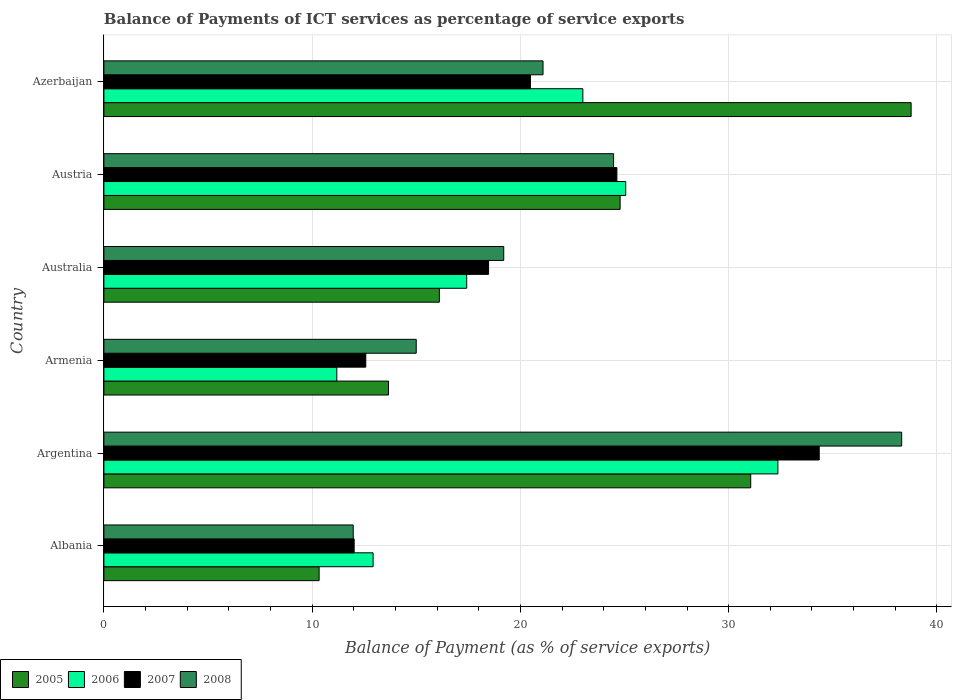How many different coloured bars are there?
Provide a succinct answer. 4. Are the number of bars per tick equal to the number of legend labels?
Offer a terse response. Yes. How many bars are there on the 6th tick from the top?
Provide a succinct answer. 4. What is the label of the 4th group of bars from the top?
Make the answer very short. Armenia. In how many cases, is the number of bars for a given country not equal to the number of legend labels?
Provide a short and direct response. 0. What is the balance of payments of ICT services in 2005 in Australia?
Keep it short and to the point. 16.11. Across all countries, what is the maximum balance of payments of ICT services in 2006?
Provide a succinct answer. 32.36. Across all countries, what is the minimum balance of payments of ICT services in 2007?
Provide a short and direct response. 12.02. In which country was the balance of payments of ICT services in 2007 maximum?
Offer a terse response. Argentina. In which country was the balance of payments of ICT services in 2005 minimum?
Ensure brevity in your answer.  Albania. What is the total balance of payments of ICT services in 2007 in the graph?
Keep it short and to the point. 122.53. What is the difference between the balance of payments of ICT services in 2007 in Argentina and that in Australia?
Make the answer very short. 15.88. What is the difference between the balance of payments of ICT services in 2006 in Albania and the balance of payments of ICT services in 2008 in Argentina?
Offer a terse response. -25.38. What is the average balance of payments of ICT services in 2007 per country?
Your answer should be compact. 20.42. What is the difference between the balance of payments of ICT services in 2008 and balance of payments of ICT services in 2005 in Armenia?
Ensure brevity in your answer.  1.33. In how many countries, is the balance of payments of ICT services in 2005 greater than 32 %?
Your answer should be compact. 1. What is the ratio of the balance of payments of ICT services in 2007 in Albania to that in Austria?
Make the answer very short. 0.49. Is the difference between the balance of payments of ICT services in 2008 in Armenia and Azerbaijan greater than the difference between the balance of payments of ICT services in 2005 in Armenia and Azerbaijan?
Ensure brevity in your answer.  Yes. What is the difference between the highest and the second highest balance of payments of ICT services in 2006?
Keep it short and to the point. 7.31. What is the difference between the highest and the lowest balance of payments of ICT services in 2005?
Give a very brief answer. 28.43. In how many countries, is the balance of payments of ICT services in 2006 greater than the average balance of payments of ICT services in 2006 taken over all countries?
Provide a short and direct response. 3. What does the 2nd bar from the top in Azerbaijan represents?
Give a very brief answer. 2007. What does the 4th bar from the bottom in Argentina represents?
Your answer should be compact. 2008. Is it the case that in every country, the sum of the balance of payments of ICT services in 2006 and balance of payments of ICT services in 2005 is greater than the balance of payments of ICT services in 2008?
Give a very brief answer. Yes. How many bars are there?
Provide a short and direct response. 24. How many countries are there in the graph?
Your response must be concise. 6. What is the difference between two consecutive major ticks on the X-axis?
Your response must be concise. 10. Are the values on the major ticks of X-axis written in scientific E-notation?
Provide a succinct answer. No. Does the graph contain grids?
Ensure brevity in your answer.  Yes. Where does the legend appear in the graph?
Offer a terse response. Bottom left. How many legend labels are there?
Make the answer very short. 4. How are the legend labels stacked?
Give a very brief answer. Horizontal. What is the title of the graph?
Give a very brief answer. Balance of Payments of ICT services as percentage of service exports. Does "2000" appear as one of the legend labels in the graph?
Offer a very short reply. No. What is the label or title of the X-axis?
Give a very brief answer. Balance of Payment (as % of service exports). What is the label or title of the Y-axis?
Keep it short and to the point. Country. What is the Balance of Payment (as % of service exports) of 2005 in Albania?
Ensure brevity in your answer.  10.34. What is the Balance of Payment (as % of service exports) of 2006 in Albania?
Your response must be concise. 12.93. What is the Balance of Payment (as % of service exports) in 2007 in Albania?
Offer a very short reply. 12.02. What is the Balance of Payment (as % of service exports) of 2008 in Albania?
Offer a terse response. 11.97. What is the Balance of Payment (as % of service exports) of 2005 in Argentina?
Make the answer very short. 31.06. What is the Balance of Payment (as % of service exports) of 2006 in Argentina?
Offer a terse response. 32.36. What is the Balance of Payment (as % of service exports) of 2007 in Argentina?
Make the answer very short. 34.35. What is the Balance of Payment (as % of service exports) of 2008 in Argentina?
Your answer should be compact. 38.31. What is the Balance of Payment (as % of service exports) in 2005 in Armenia?
Keep it short and to the point. 13.67. What is the Balance of Payment (as % of service exports) of 2006 in Armenia?
Your answer should be compact. 11.18. What is the Balance of Payment (as % of service exports) of 2007 in Armenia?
Your response must be concise. 12.58. What is the Balance of Payment (as % of service exports) of 2008 in Armenia?
Your response must be concise. 15. What is the Balance of Payment (as % of service exports) of 2005 in Australia?
Your answer should be compact. 16.11. What is the Balance of Payment (as % of service exports) of 2006 in Australia?
Offer a very short reply. 17.42. What is the Balance of Payment (as % of service exports) in 2007 in Australia?
Ensure brevity in your answer.  18.47. What is the Balance of Payment (as % of service exports) in 2008 in Australia?
Give a very brief answer. 19.2. What is the Balance of Payment (as % of service exports) of 2005 in Austria?
Your response must be concise. 24.79. What is the Balance of Payment (as % of service exports) in 2006 in Austria?
Your answer should be very brief. 25.06. What is the Balance of Payment (as % of service exports) in 2007 in Austria?
Your answer should be compact. 24.63. What is the Balance of Payment (as % of service exports) of 2008 in Austria?
Make the answer very short. 24.47. What is the Balance of Payment (as % of service exports) of 2005 in Azerbaijan?
Offer a very short reply. 38.76. What is the Balance of Payment (as % of service exports) in 2006 in Azerbaijan?
Ensure brevity in your answer.  23. What is the Balance of Payment (as % of service exports) in 2007 in Azerbaijan?
Offer a terse response. 20.48. What is the Balance of Payment (as % of service exports) of 2008 in Azerbaijan?
Offer a terse response. 21.09. Across all countries, what is the maximum Balance of Payment (as % of service exports) of 2005?
Your answer should be very brief. 38.76. Across all countries, what is the maximum Balance of Payment (as % of service exports) of 2006?
Offer a terse response. 32.36. Across all countries, what is the maximum Balance of Payment (as % of service exports) in 2007?
Your response must be concise. 34.35. Across all countries, what is the maximum Balance of Payment (as % of service exports) in 2008?
Your answer should be very brief. 38.31. Across all countries, what is the minimum Balance of Payment (as % of service exports) in 2005?
Offer a terse response. 10.34. Across all countries, what is the minimum Balance of Payment (as % of service exports) in 2006?
Ensure brevity in your answer.  11.18. Across all countries, what is the minimum Balance of Payment (as % of service exports) in 2007?
Keep it short and to the point. 12.02. Across all countries, what is the minimum Balance of Payment (as % of service exports) of 2008?
Your response must be concise. 11.97. What is the total Balance of Payment (as % of service exports) in 2005 in the graph?
Your response must be concise. 134.72. What is the total Balance of Payment (as % of service exports) in 2006 in the graph?
Give a very brief answer. 121.95. What is the total Balance of Payment (as % of service exports) in 2007 in the graph?
Offer a very short reply. 122.53. What is the total Balance of Payment (as % of service exports) in 2008 in the graph?
Your answer should be very brief. 130.04. What is the difference between the Balance of Payment (as % of service exports) of 2005 in Albania and that in Argentina?
Your response must be concise. -20.72. What is the difference between the Balance of Payment (as % of service exports) of 2006 in Albania and that in Argentina?
Make the answer very short. -19.44. What is the difference between the Balance of Payment (as % of service exports) of 2007 in Albania and that in Argentina?
Your answer should be compact. -22.33. What is the difference between the Balance of Payment (as % of service exports) of 2008 in Albania and that in Argentina?
Your response must be concise. -26.34. What is the difference between the Balance of Payment (as % of service exports) in 2005 in Albania and that in Armenia?
Give a very brief answer. -3.33. What is the difference between the Balance of Payment (as % of service exports) in 2006 in Albania and that in Armenia?
Offer a terse response. 1.74. What is the difference between the Balance of Payment (as % of service exports) in 2007 in Albania and that in Armenia?
Keep it short and to the point. -0.56. What is the difference between the Balance of Payment (as % of service exports) in 2008 in Albania and that in Armenia?
Provide a short and direct response. -3.03. What is the difference between the Balance of Payment (as % of service exports) in 2005 in Albania and that in Australia?
Your response must be concise. -5.77. What is the difference between the Balance of Payment (as % of service exports) in 2006 in Albania and that in Australia?
Give a very brief answer. -4.5. What is the difference between the Balance of Payment (as % of service exports) in 2007 in Albania and that in Australia?
Keep it short and to the point. -6.45. What is the difference between the Balance of Payment (as % of service exports) of 2008 in Albania and that in Australia?
Offer a terse response. -7.23. What is the difference between the Balance of Payment (as % of service exports) of 2005 in Albania and that in Austria?
Provide a succinct answer. -14.45. What is the difference between the Balance of Payment (as % of service exports) of 2006 in Albania and that in Austria?
Your response must be concise. -12.13. What is the difference between the Balance of Payment (as % of service exports) in 2007 in Albania and that in Austria?
Offer a very short reply. -12.62. What is the difference between the Balance of Payment (as % of service exports) of 2008 in Albania and that in Austria?
Provide a succinct answer. -12.5. What is the difference between the Balance of Payment (as % of service exports) in 2005 in Albania and that in Azerbaijan?
Offer a terse response. -28.43. What is the difference between the Balance of Payment (as % of service exports) of 2006 in Albania and that in Azerbaijan?
Ensure brevity in your answer.  -10.07. What is the difference between the Balance of Payment (as % of service exports) of 2007 in Albania and that in Azerbaijan?
Give a very brief answer. -8.46. What is the difference between the Balance of Payment (as % of service exports) in 2008 in Albania and that in Azerbaijan?
Ensure brevity in your answer.  -9.11. What is the difference between the Balance of Payment (as % of service exports) of 2005 in Argentina and that in Armenia?
Provide a short and direct response. 17.39. What is the difference between the Balance of Payment (as % of service exports) in 2006 in Argentina and that in Armenia?
Give a very brief answer. 21.18. What is the difference between the Balance of Payment (as % of service exports) of 2007 in Argentina and that in Armenia?
Offer a terse response. 21.77. What is the difference between the Balance of Payment (as % of service exports) in 2008 in Argentina and that in Armenia?
Give a very brief answer. 23.31. What is the difference between the Balance of Payment (as % of service exports) in 2005 in Argentina and that in Australia?
Give a very brief answer. 14.95. What is the difference between the Balance of Payment (as % of service exports) in 2006 in Argentina and that in Australia?
Your answer should be compact. 14.94. What is the difference between the Balance of Payment (as % of service exports) of 2007 in Argentina and that in Australia?
Provide a succinct answer. 15.88. What is the difference between the Balance of Payment (as % of service exports) of 2008 in Argentina and that in Australia?
Ensure brevity in your answer.  19.11. What is the difference between the Balance of Payment (as % of service exports) of 2005 in Argentina and that in Austria?
Offer a terse response. 6.27. What is the difference between the Balance of Payment (as % of service exports) of 2006 in Argentina and that in Austria?
Your answer should be very brief. 7.31. What is the difference between the Balance of Payment (as % of service exports) of 2007 in Argentina and that in Austria?
Keep it short and to the point. 9.72. What is the difference between the Balance of Payment (as % of service exports) in 2008 in Argentina and that in Austria?
Offer a very short reply. 13.83. What is the difference between the Balance of Payment (as % of service exports) in 2005 in Argentina and that in Azerbaijan?
Your response must be concise. -7.7. What is the difference between the Balance of Payment (as % of service exports) of 2006 in Argentina and that in Azerbaijan?
Make the answer very short. 9.37. What is the difference between the Balance of Payment (as % of service exports) in 2007 in Argentina and that in Azerbaijan?
Offer a very short reply. 13.87. What is the difference between the Balance of Payment (as % of service exports) in 2008 in Argentina and that in Azerbaijan?
Make the answer very short. 17.22. What is the difference between the Balance of Payment (as % of service exports) of 2005 in Armenia and that in Australia?
Offer a terse response. -2.44. What is the difference between the Balance of Payment (as % of service exports) in 2006 in Armenia and that in Australia?
Offer a very short reply. -6.24. What is the difference between the Balance of Payment (as % of service exports) in 2007 in Armenia and that in Australia?
Your response must be concise. -5.9. What is the difference between the Balance of Payment (as % of service exports) in 2008 in Armenia and that in Australia?
Keep it short and to the point. -4.2. What is the difference between the Balance of Payment (as % of service exports) of 2005 in Armenia and that in Austria?
Offer a terse response. -11.12. What is the difference between the Balance of Payment (as % of service exports) of 2006 in Armenia and that in Austria?
Offer a very short reply. -13.87. What is the difference between the Balance of Payment (as % of service exports) in 2007 in Armenia and that in Austria?
Your answer should be very brief. -12.06. What is the difference between the Balance of Payment (as % of service exports) of 2008 in Armenia and that in Austria?
Your answer should be very brief. -9.48. What is the difference between the Balance of Payment (as % of service exports) in 2005 in Armenia and that in Azerbaijan?
Your response must be concise. -25.1. What is the difference between the Balance of Payment (as % of service exports) in 2006 in Armenia and that in Azerbaijan?
Your answer should be compact. -11.81. What is the difference between the Balance of Payment (as % of service exports) of 2007 in Armenia and that in Azerbaijan?
Ensure brevity in your answer.  -7.9. What is the difference between the Balance of Payment (as % of service exports) in 2008 in Armenia and that in Azerbaijan?
Your answer should be very brief. -6.09. What is the difference between the Balance of Payment (as % of service exports) of 2005 in Australia and that in Austria?
Provide a short and direct response. -8.68. What is the difference between the Balance of Payment (as % of service exports) of 2006 in Australia and that in Austria?
Make the answer very short. -7.63. What is the difference between the Balance of Payment (as % of service exports) in 2007 in Australia and that in Austria?
Ensure brevity in your answer.  -6.16. What is the difference between the Balance of Payment (as % of service exports) in 2008 in Australia and that in Austria?
Make the answer very short. -5.28. What is the difference between the Balance of Payment (as % of service exports) in 2005 in Australia and that in Azerbaijan?
Your answer should be compact. -22.65. What is the difference between the Balance of Payment (as % of service exports) of 2006 in Australia and that in Azerbaijan?
Keep it short and to the point. -5.58. What is the difference between the Balance of Payment (as % of service exports) in 2007 in Australia and that in Azerbaijan?
Your answer should be compact. -2.01. What is the difference between the Balance of Payment (as % of service exports) of 2008 in Australia and that in Azerbaijan?
Your response must be concise. -1.89. What is the difference between the Balance of Payment (as % of service exports) in 2005 in Austria and that in Azerbaijan?
Your response must be concise. -13.97. What is the difference between the Balance of Payment (as % of service exports) in 2006 in Austria and that in Azerbaijan?
Provide a succinct answer. 2.06. What is the difference between the Balance of Payment (as % of service exports) in 2007 in Austria and that in Azerbaijan?
Make the answer very short. 4.15. What is the difference between the Balance of Payment (as % of service exports) in 2008 in Austria and that in Azerbaijan?
Give a very brief answer. 3.39. What is the difference between the Balance of Payment (as % of service exports) in 2005 in Albania and the Balance of Payment (as % of service exports) in 2006 in Argentina?
Offer a very short reply. -22.03. What is the difference between the Balance of Payment (as % of service exports) in 2005 in Albania and the Balance of Payment (as % of service exports) in 2007 in Argentina?
Ensure brevity in your answer.  -24.01. What is the difference between the Balance of Payment (as % of service exports) of 2005 in Albania and the Balance of Payment (as % of service exports) of 2008 in Argentina?
Your answer should be very brief. -27.97. What is the difference between the Balance of Payment (as % of service exports) of 2006 in Albania and the Balance of Payment (as % of service exports) of 2007 in Argentina?
Make the answer very short. -21.42. What is the difference between the Balance of Payment (as % of service exports) of 2006 in Albania and the Balance of Payment (as % of service exports) of 2008 in Argentina?
Give a very brief answer. -25.38. What is the difference between the Balance of Payment (as % of service exports) in 2007 in Albania and the Balance of Payment (as % of service exports) in 2008 in Argentina?
Provide a succinct answer. -26.29. What is the difference between the Balance of Payment (as % of service exports) in 2005 in Albania and the Balance of Payment (as % of service exports) in 2006 in Armenia?
Offer a very short reply. -0.85. What is the difference between the Balance of Payment (as % of service exports) of 2005 in Albania and the Balance of Payment (as % of service exports) of 2007 in Armenia?
Provide a succinct answer. -2.24. What is the difference between the Balance of Payment (as % of service exports) of 2005 in Albania and the Balance of Payment (as % of service exports) of 2008 in Armenia?
Offer a terse response. -4.66. What is the difference between the Balance of Payment (as % of service exports) in 2006 in Albania and the Balance of Payment (as % of service exports) in 2007 in Armenia?
Your response must be concise. 0.35. What is the difference between the Balance of Payment (as % of service exports) in 2006 in Albania and the Balance of Payment (as % of service exports) in 2008 in Armenia?
Keep it short and to the point. -2.07. What is the difference between the Balance of Payment (as % of service exports) of 2007 in Albania and the Balance of Payment (as % of service exports) of 2008 in Armenia?
Give a very brief answer. -2.98. What is the difference between the Balance of Payment (as % of service exports) of 2005 in Albania and the Balance of Payment (as % of service exports) of 2006 in Australia?
Offer a very short reply. -7.09. What is the difference between the Balance of Payment (as % of service exports) of 2005 in Albania and the Balance of Payment (as % of service exports) of 2007 in Australia?
Provide a succinct answer. -8.14. What is the difference between the Balance of Payment (as % of service exports) of 2005 in Albania and the Balance of Payment (as % of service exports) of 2008 in Australia?
Your response must be concise. -8.86. What is the difference between the Balance of Payment (as % of service exports) of 2006 in Albania and the Balance of Payment (as % of service exports) of 2007 in Australia?
Ensure brevity in your answer.  -5.55. What is the difference between the Balance of Payment (as % of service exports) of 2006 in Albania and the Balance of Payment (as % of service exports) of 2008 in Australia?
Make the answer very short. -6.27. What is the difference between the Balance of Payment (as % of service exports) of 2007 in Albania and the Balance of Payment (as % of service exports) of 2008 in Australia?
Your response must be concise. -7.18. What is the difference between the Balance of Payment (as % of service exports) of 2005 in Albania and the Balance of Payment (as % of service exports) of 2006 in Austria?
Ensure brevity in your answer.  -14.72. What is the difference between the Balance of Payment (as % of service exports) of 2005 in Albania and the Balance of Payment (as % of service exports) of 2007 in Austria?
Your answer should be very brief. -14.3. What is the difference between the Balance of Payment (as % of service exports) of 2005 in Albania and the Balance of Payment (as % of service exports) of 2008 in Austria?
Give a very brief answer. -14.14. What is the difference between the Balance of Payment (as % of service exports) in 2006 in Albania and the Balance of Payment (as % of service exports) in 2007 in Austria?
Your answer should be very brief. -11.71. What is the difference between the Balance of Payment (as % of service exports) of 2006 in Albania and the Balance of Payment (as % of service exports) of 2008 in Austria?
Provide a short and direct response. -11.55. What is the difference between the Balance of Payment (as % of service exports) of 2007 in Albania and the Balance of Payment (as % of service exports) of 2008 in Austria?
Make the answer very short. -12.46. What is the difference between the Balance of Payment (as % of service exports) of 2005 in Albania and the Balance of Payment (as % of service exports) of 2006 in Azerbaijan?
Your answer should be compact. -12.66. What is the difference between the Balance of Payment (as % of service exports) of 2005 in Albania and the Balance of Payment (as % of service exports) of 2007 in Azerbaijan?
Your answer should be very brief. -10.15. What is the difference between the Balance of Payment (as % of service exports) in 2005 in Albania and the Balance of Payment (as % of service exports) in 2008 in Azerbaijan?
Offer a very short reply. -10.75. What is the difference between the Balance of Payment (as % of service exports) in 2006 in Albania and the Balance of Payment (as % of service exports) in 2007 in Azerbaijan?
Your answer should be very brief. -7.55. What is the difference between the Balance of Payment (as % of service exports) in 2006 in Albania and the Balance of Payment (as % of service exports) in 2008 in Azerbaijan?
Your response must be concise. -8.16. What is the difference between the Balance of Payment (as % of service exports) of 2007 in Albania and the Balance of Payment (as % of service exports) of 2008 in Azerbaijan?
Your answer should be compact. -9.07. What is the difference between the Balance of Payment (as % of service exports) in 2005 in Argentina and the Balance of Payment (as % of service exports) in 2006 in Armenia?
Ensure brevity in your answer.  19.87. What is the difference between the Balance of Payment (as % of service exports) in 2005 in Argentina and the Balance of Payment (as % of service exports) in 2007 in Armenia?
Give a very brief answer. 18.48. What is the difference between the Balance of Payment (as % of service exports) of 2005 in Argentina and the Balance of Payment (as % of service exports) of 2008 in Armenia?
Your response must be concise. 16.06. What is the difference between the Balance of Payment (as % of service exports) in 2006 in Argentina and the Balance of Payment (as % of service exports) in 2007 in Armenia?
Offer a terse response. 19.79. What is the difference between the Balance of Payment (as % of service exports) of 2006 in Argentina and the Balance of Payment (as % of service exports) of 2008 in Armenia?
Offer a very short reply. 17.37. What is the difference between the Balance of Payment (as % of service exports) of 2007 in Argentina and the Balance of Payment (as % of service exports) of 2008 in Armenia?
Give a very brief answer. 19.35. What is the difference between the Balance of Payment (as % of service exports) of 2005 in Argentina and the Balance of Payment (as % of service exports) of 2006 in Australia?
Offer a very short reply. 13.64. What is the difference between the Balance of Payment (as % of service exports) of 2005 in Argentina and the Balance of Payment (as % of service exports) of 2007 in Australia?
Ensure brevity in your answer.  12.59. What is the difference between the Balance of Payment (as % of service exports) in 2005 in Argentina and the Balance of Payment (as % of service exports) in 2008 in Australia?
Make the answer very short. 11.86. What is the difference between the Balance of Payment (as % of service exports) of 2006 in Argentina and the Balance of Payment (as % of service exports) of 2007 in Australia?
Make the answer very short. 13.89. What is the difference between the Balance of Payment (as % of service exports) of 2006 in Argentina and the Balance of Payment (as % of service exports) of 2008 in Australia?
Your answer should be compact. 13.17. What is the difference between the Balance of Payment (as % of service exports) in 2007 in Argentina and the Balance of Payment (as % of service exports) in 2008 in Australia?
Offer a terse response. 15.15. What is the difference between the Balance of Payment (as % of service exports) of 2005 in Argentina and the Balance of Payment (as % of service exports) of 2006 in Austria?
Give a very brief answer. 6. What is the difference between the Balance of Payment (as % of service exports) in 2005 in Argentina and the Balance of Payment (as % of service exports) in 2007 in Austria?
Provide a succinct answer. 6.43. What is the difference between the Balance of Payment (as % of service exports) in 2005 in Argentina and the Balance of Payment (as % of service exports) in 2008 in Austria?
Your response must be concise. 6.58. What is the difference between the Balance of Payment (as % of service exports) of 2006 in Argentina and the Balance of Payment (as % of service exports) of 2007 in Austria?
Provide a short and direct response. 7.73. What is the difference between the Balance of Payment (as % of service exports) of 2006 in Argentina and the Balance of Payment (as % of service exports) of 2008 in Austria?
Your response must be concise. 7.89. What is the difference between the Balance of Payment (as % of service exports) in 2007 in Argentina and the Balance of Payment (as % of service exports) in 2008 in Austria?
Provide a short and direct response. 9.87. What is the difference between the Balance of Payment (as % of service exports) in 2005 in Argentina and the Balance of Payment (as % of service exports) in 2006 in Azerbaijan?
Provide a succinct answer. 8.06. What is the difference between the Balance of Payment (as % of service exports) of 2005 in Argentina and the Balance of Payment (as % of service exports) of 2007 in Azerbaijan?
Offer a terse response. 10.58. What is the difference between the Balance of Payment (as % of service exports) in 2005 in Argentina and the Balance of Payment (as % of service exports) in 2008 in Azerbaijan?
Provide a succinct answer. 9.97. What is the difference between the Balance of Payment (as % of service exports) of 2006 in Argentina and the Balance of Payment (as % of service exports) of 2007 in Azerbaijan?
Make the answer very short. 11.88. What is the difference between the Balance of Payment (as % of service exports) of 2006 in Argentina and the Balance of Payment (as % of service exports) of 2008 in Azerbaijan?
Keep it short and to the point. 11.28. What is the difference between the Balance of Payment (as % of service exports) of 2007 in Argentina and the Balance of Payment (as % of service exports) of 2008 in Azerbaijan?
Offer a very short reply. 13.26. What is the difference between the Balance of Payment (as % of service exports) of 2005 in Armenia and the Balance of Payment (as % of service exports) of 2006 in Australia?
Provide a short and direct response. -3.76. What is the difference between the Balance of Payment (as % of service exports) of 2005 in Armenia and the Balance of Payment (as % of service exports) of 2007 in Australia?
Offer a terse response. -4.81. What is the difference between the Balance of Payment (as % of service exports) of 2005 in Armenia and the Balance of Payment (as % of service exports) of 2008 in Australia?
Your response must be concise. -5.53. What is the difference between the Balance of Payment (as % of service exports) in 2006 in Armenia and the Balance of Payment (as % of service exports) in 2007 in Australia?
Make the answer very short. -7.29. What is the difference between the Balance of Payment (as % of service exports) of 2006 in Armenia and the Balance of Payment (as % of service exports) of 2008 in Australia?
Your answer should be compact. -8.02. What is the difference between the Balance of Payment (as % of service exports) of 2007 in Armenia and the Balance of Payment (as % of service exports) of 2008 in Australia?
Your answer should be compact. -6.62. What is the difference between the Balance of Payment (as % of service exports) of 2005 in Armenia and the Balance of Payment (as % of service exports) of 2006 in Austria?
Offer a very short reply. -11.39. What is the difference between the Balance of Payment (as % of service exports) of 2005 in Armenia and the Balance of Payment (as % of service exports) of 2007 in Austria?
Provide a succinct answer. -10.97. What is the difference between the Balance of Payment (as % of service exports) of 2005 in Armenia and the Balance of Payment (as % of service exports) of 2008 in Austria?
Offer a very short reply. -10.81. What is the difference between the Balance of Payment (as % of service exports) of 2006 in Armenia and the Balance of Payment (as % of service exports) of 2007 in Austria?
Your answer should be compact. -13.45. What is the difference between the Balance of Payment (as % of service exports) of 2006 in Armenia and the Balance of Payment (as % of service exports) of 2008 in Austria?
Offer a terse response. -13.29. What is the difference between the Balance of Payment (as % of service exports) of 2007 in Armenia and the Balance of Payment (as % of service exports) of 2008 in Austria?
Give a very brief answer. -11.9. What is the difference between the Balance of Payment (as % of service exports) of 2005 in Armenia and the Balance of Payment (as % of service exports) of 2006 in Azerbaijan?
Provide a succinct answer. -9.33. What is the difference between the Balance of Payment (as % of service exports) in 2005 in Armenia and the Balance of Payment (as % of service exports) in 2007 in Azerbaijan?
Offer a very short reply. -6.81. What is the difference between the Balance of Payment (as % of service exports) of 2005 in Armenia and the Balance of Payment (as % of service exports) of 2008 in Azerbaijan?
Offer a very short reply. -7.42. What is the difference between the Balance of Payment (as % of service exports) in 2006 in Armenia and the Balance of Payment (as % of service exports) in 2007 in Azerbaijan?
Your answer should be very brief. -9.3. What is the difference between the Balance of Payment (as % of service exports) in 2006 in Armenia and the Balance of Payment (as % of service exports) in 2008 in Azerbaijan?
Your response must be concise. -9.9. What is the difference between the Balance of Payment (as % of service exports) of 2007 in Armenia and the Balance of Payment (as % of service exports) of 2008 in Azerbaijan?
Offer a terse response. -8.51. What is the difference between the Balance of Payment (as % of service exports) of 2005 in Australia and the Balance of Payment (as % of service exports) of 2006 in Austria?
Ensure brevity in your answer.  -8.95. What is the difference between the Balance of Payment (as % of service exports) of 2005 in Australia and the Balance of Payment (as % of service exports) of 2007 in Austria?
Offer a very short reply. -8.52. What is the difference between the Balance of Payment (as % of service exports) of 2005 in Australia and the Balance of Payment (as % of service exports) of 2008 in Austria?
Provide a short and direct response. -8.37. What is the difference between the Balance of Payment (as % of service exports) of 2006 in Australia and the Balance of Payment (as % of service exports) of 2007 in Austria?
Provide a succinct answer. -7.21. What is the difference between the Balance of Payment (as % of service exports) of 2006 in Australia and the Balance of Payment (as % of service exports) of 2008 in Austria?
Your response must be concise. -7.05. What is the difference between the Balance of Payment (as % of service exports) of 2007 in Australia and the Balance of Payment (as % of service exports) of 2008 in Austria?
Provide a short and direct response. -6. What is the difference between the Balance of Payment (as % of service exports) in 2005 in Australia and the Balance of Payment (as % of service exports) in 2006 in Azerbaijan?
Your response must be concise. -6.89. What is the difference between the Balance of Payment (as % of service exports) in 2005 in Australia and the Balance of Payment (as % of service exports) in 2007 in Azerbaijan?
Offer a very short reply. -4.37. What is the difference between the Balance of Payment (as % of service exports) in 2005 in Australia and the Balance of Payment (as % of service exports) in 2008 in Azerbaijan?
Your answer should be very brief. -4.98. What is the difference between the Balance of Payment (as % of service exports) of 2006 in Australia and the Balance of Payment (as % of service exports) of 2007 in Azerbaijan?
Give a very brief answer. -3.06. What is the difference between the Balance of Payment (as % of service exports) in 2006 in Australia and the Balance of Payment (as % of service exports) in 2008 in Azerbaijan?
Your answer should be compact. -3.66. What is the difference between the Balance of Payment (as % of service exports) of 2007 in Australia and the Balance of Payment (as % of service exports) of 2008 in Azerbaijan?
Your answer should be compact. -2.61. What is the difference between the Balance of Payment (as % of service exports) in 2005 in Austria and the Balance of Payment (as % of service exports) in 2006 in Azerbaijan?
Your response must be concise. 1.79. What is the difference between the Balance of Payment (as % of service exports) of 2005 in Austria and the Balance of Payment (as % of service exports) of 2007 in Azerbaijan?
Your answer should be compact. 4.31. What is the difference between the Balance of Payment (as % of service exports) of 2005 in Austria and the Balance of Payment (as % of service exports) of 2008 in Azerbaijan?
Provide a succinct answer. 3.7. What is the difference between the Balance of Payment (as % of service exports) in 2006 in Austria and the Balance of Payment (as % of service exports) in 2007 in Azerbaijan?
Offer a terse response. 4.58. What is the difference between the Balance of Payment (as % of service exports) of 2006 in Austria and the Balance of Payment (as % of service exports) of 2008 in Azerbaijan?
Your answer should be very brief. 3.97. What is the difference between the Balance of Payment (as % of service exports) of 2007 in Austria and the Balance of Payment (as % of service exports) of 2008 in Azerbaijan?
Give a very brief answer. 3.55. What is the average Balance of Payment (as % of service exports) in 2005 per country?
Ensure brevity in your answer.  22.45. What is the average Balance of Payment (as % of service exports) of 2006 per country?
Offer a terse response. 20.33. What is the average Balance of Payment (as % of service exports) in 2007 per country?
Offer a terse response. 20.42. What is the average Balance of Payment (as % of service exports) of 2008 per country?
Your answer should be compact. 21.67. What is the difference between the Balance of Payment (as % of service exports) in 2005 and Balance of Payment (as % of service exports) in 2006 in Albania?
Your answer should be compact. -2.59. What is the difference between the Balance of Payment (as % of service exports) of 2005 and Balance of Payment (as % of service exports) of 2007 in Albania?
Make the answer very short. -1.68. What is the difference between the Balance of Payment (as % of service exports) of 2005 and Balance of Payment (as % of service exports) of 2008 in Albania?
Keep it short and to the point. -1.64. What is the difference between the Balance of Payment (as % of service exports) in 2006 and Balance of Payment (as % of service exports) in 2007 in Albania?
Make the answer very short. 0.91. What is the difference between the Balance of Payment (as % of service exports) in 2006 and Balance of Payment (as % of service exports) in 2008 in Albania?
Your response must be concise. 0.95. What is the difference between the Balance of Payment (as % of service exports) of 2007 and Balance of Payment (as % of service exports) of 2008 in Albania?
Ensure brevity in your answer.  0.04. What is the difference between the Balance of Payment (as % of service exports) in 2005 and Balance of Payment (as % of service exports) in 2006 in Argentina?
Provide a succinct answer. -1.31. What is the difference between the Balance of Payment (as % of service exports) in 2005 and Balance of Payment (as % of service exports) in 2007 in Argentina?
Offer a terse response. -3.29. What is the difference between the Balance of Payment (as % of service exports) in 2005 and Balance of Payment (as % of service exports) in 2008 in Argentina?
Your answer should be compact. -7.25. What is the difference between the Balance of Payment (as % of service exports) in 2006 and Balance of Payment (as % of service exports) in 2007 in Argentina?
Give a very brief answer. -1.98. What is the difference between the Balance of Payment (as % of service exports) in 2006 and Balance of Payment (as % of service exports) in 2008 in Argentina?
Give a very brief answer. -5.94. What is the difference between the Balance of Payment (as % of service exports) of 2007 and Balance of Payment (as % of service exports) of 2008 in Argentina?
Make the answer very short. -3.96. What is the difference between the Balance of Payment (as % of service exports) of 2005 and Balance of Payment (as % of service exports) of 2006 in Armenia?
Ensure brevity in your answer.  2.48. What is the difference between the Balance of Payment (as % of service exports) in 2005 and Balance of Payment (as % of service exports) in 2007 in Armenia?
Offer a very short reply. 1.09. What is the difference between the Balance of Payment (as % of service exports) in 2005 and Balance of Payment (as % of service exports) in 2008 in Armenia?
Provide a short and direct response. -1.33. What is the difference between the Balance of Payment (as % of service exports) of 2006 and Balance of Payment (as % of service exports) of 2007 in Armenia?
Your response must be concise. -1.39. What is the difference between the Balance of Payment (as % of service exports) of 2006 and Balance of Payment (as % of service exports) of 2008 in Armenia?
Ensure brevity in your answer.  -3.81. What is the difference between the Balance of Payment (as % of service exports) of 2007 and Balance of Payment (as % of service exports) of 2008 in Armenia?
Your answer should be compact. -2.42. What is the difference between the Balance of Payment (as % of service exports) in 2005 and Balance of Payment (as % of service exports) in 2006 in Australia?
Give a very brief answer. -1.31. What is the difference between the Balance of Payment (as % of service exports) in 2005 and Balance of Payment (as % of service exports) in 2007 in Australia?
Your answer should be compact. -2.36. What is the difference between the Balance of Payment (as % of service exports) of 2005 and Balance of Payment (as % of service exports) of 2008 in Australia?
Your answer should be compact. -3.09. What is the difference between the Balance of Payment (as % of service exports) in 2006 and Balance of Payment (as % of service exports) in 2007 in Australia?
Ensure brevity in your answer.  -1.05. What is the difference between the Balance of Payment (as % of service exports) in 2006 and Balance of Payment (as % of service exports) in 2008 in Australia?
Your answer should be compact. -1.78. What is the difference between the Balance of Payment (as % of service exports) in 2007 and Balance of Payment (as % of service exports) in 2008 in Australia?
Your answer should be compact. -0.73. What is the difference between the Balance of Payment (as % of service exports) in 2005 and Balance of Payment (as % of service exports) in 2006 in Austria?
Ensure brevity in your answer.  -0.27. What is the difference between the Balance of Payment (as % of service exports) of 2005 and Balance of Payment (as % of service exports) of 2007 in Austria?
Ensure brevity in your answer.  0.16. What is the difference between the Balance of Payment (as % of service exports) of 2005 and Balance of Payment (as % of service exports) of 2008 in Austria?
Your answer should be compact. 0.31. What is the difference between the Balance of Payment (as % of service exports) of 2006 and Balance of Payment (as % of service exports) of 2007 in Austria?
Your response must be concise. 0.42. What is the difference between the Balance of Payment (as % of service exports) of 2006 and Balance of Payment (as % of service exports) of 2008 in Austria?
Your answer should be very brief. 0.58. What is the difference between the Balance of Payment (as % of service exports) in 2007 and Balance of Payment (as % of service exports) in 2008 in Austria?
Provide a short and direct response. 0.16. What is the difference between the Balance of Payment (as % of service exports) of 2005 and Balance of Payment (as % of service exports) of 2006 in Azerbaijan?
Make the answer very short. 15.76. What is the difference between the Balance of Payment (as % of service exports) in 2005 and Balance of Payment (as % of service exports) in 2007 in Azerbaijan?
Your response must be concise. 18.28. What is the difference between the Balance of Payment (as % of service exports) of 2005 and Balance of Payment (as % of service exports) of 2008 in Azerbaijan?
Your response must be concise. 17.68. What is the difference between the Balance of Payment (as % of service exports) in 2006 and Balance of Payment (as % of service exports) in 2007 in Azerbaijan?
Ensure brevity in your answer.  2.52. What is the difference between the Balance of Payment (as % of service exports) of 2006 and Balance of Payment (as % of service exports) of 2008 in Azerbaijan?
Your answer should be compact. 1.91. What is the difference between the Balance of Payment (as % of service exports) of 2007 and Balance of Payment (as % of service exports) of 2008 in Azerbaijan?
Make the answer very short. -0.61. What is the ratio of the Balance of Payment (as % of service exports) of 2005 in Albania to that in Argentina?
Provide a succinct answer. 0.33. What is the ratio of the Balance of Payment (as % of service exports) of 2006 in Albania to that in Argentina?
Your answer should be very brief. 0.4. What is the ratio of the Balance of Payment (as % of service exports) in 2007 in Albania to that in Argentina?
Provide a succinct answer. 0.35. What is the ratio of the Balance of Payment (as % of service exports) of 2008 in Albania to that in Argentina?
Your answer should be very brief. 0.31. What is the ratio of the Balance of Payment (as % of service exports) in 2005 in Albania to that in Armenia?
Your answer should be compact. 0.76. What is the ratio of the Balance of Payment (as % of service exports) of 2006 in Albania to that in Armenia?
Make the answer very short. 1.16. What is the ratio of the Balance of Payment (as % of service exports) in 2007 in Albania to that in Armenia?
Give a very brief answer. 0.96. What is the ratio of the Balance of Payment (as % of service exports) in 2008 in Albania to that in Armenia?
Provide a succinct answer. 0.8. What is the ratio of the Balance of Payment (as % of service exports) in 2005 in Albania to that in Australia?
Provide a short and direct response. 0.64. What is the ratio of the Balance of Payment (as % of service exports) of 2006 in Albania to that in Australia?
Your response must be concise. 0.74. What is the ratio of the Balance of Payment (as % of service exports) of 2007 in Albania to that in Australia?
Offer a very short reply. 0.65. What is the ratio of the Balance of Payment (as % of service exports) of 2008 in Albania to that in Australia?
Give a very brief answer. 0.62. What is the ratio of the Balance of Payment (as % of service exports) in 2005 in Albania to that in Austria?
Ensure brevity in your answer.  0.42. What is the ratio of the Balance of Payment (as % of service exports) in 2006 in Albania to that in Austria?
Your answer should be compact. 0.52. What is the ratio of the Balance of Payment (as % of service exports) in 2007 in Albania to that in Austria?
Keep it short and to the point. 0.49. What is the ratio of the Balance of Payment (as % of service exports) in 2008 in Albania to that in Austria?
Provide a short and direct response. 0.49. What is the ratio of the Balance of Payment (as % of service exports) in 2005 in Albania to that in Azerbaijan?
Ensure brevity in your answer.  0.27. What is the ratio of the Balance of Payment (as % of service exports) in 2006 in Albania to that in Azerbaijan?
Your response must be concise. 0.56. What is the ratio of the Balance of Payment (as % of service exports) in 2007 in Albania to that in Azerbaijan?
Ensure brevity in your answer.  0.59. What is the ratio of the Balance of Payment (as % of service exports) of 2008 in Albania to that in Azerbaijan?
Your answer should be very brief. 0.57. What is the ratio of the Balance of Payment (as % of service exports) in 2005 in Argentina to that in Armenia?
Offer a terse response. 2.27. What is the ratio of the Balance of Payment (as % of service exports) of 2006 in Argentina to that in Armenia?
Your answer should be very brief. 2.89. What is the ratio of the Balance of Payment (as % of service exports) of 2007 in Argentina to that in Armenia?
Give a very brief answer. 2.73. What is the ratio of the Balance of Payment (as % of service exports) in 2008 in Argentina to that in Armenia?
Your answer should be very brief. 2.55. What is the ratio of the Balance of Payment (as % of service exports) in 2005 in Argentina to that in Australia?
Offer a terse response. 1.93. What is the ratio of the Balance of Payment (as % of service exports) of 2006 in Argentina to that in Australia?
Keep it short and to the point. 1.86. What is the ratio of the Balance of Payment (as % of service exports) in 2007 in Argentina to that in Australia?
Offer a terse response. 1.86. What is the ratio of the Balance of Payment (as % of service exports) in 2008 in Argentina to that in Australia?
Make the answer very short. 2. What is the ratio of the Balance of Payment (as % of service exports) of 2005 in Argentina to that in Austria?
Give a very brief answer. 1.25. What is the ratio of the Balance of Payment (as % of service exports) in 2006 in Argentina to that in Austria?
Offer a terse response. 1.29. What is the ratio of the Balance of Payment (as % of service exports) of 2007 in Argentina to that in Austria?
Your answer should be very brief. 1.39. What is the ratio of the Balance of Payment (as % of service exports) of 2008 in Argentina to that in Austria?
Give a very brief answer. 1.57. What is the ratio of the Balance of Payment (as % of service exports) in 2005 in Argentina to that in Azerbaijan?
Offer a very short reply. 0.8. What is the ratio of the Balance of Payment (as % of service exports) in 2006 in Argentina to that in Azerbaijan?
Your answer should be compact. 1.41. What is the ratio of the Balance of Payment (as % of service exports) of 2007 in Argentina to that in Azerbaijan?
Your answer should be very brief. 1.68. What is the ratio of the Balance of Payment (as % of service exports) in 2008 in Argentina to that in Azerbaijan?
Keep it short and to the point. 1.82. What is the ratio of the Balance of Payment (as % of service exports) in 2005 in Armenia to that in Australia?
Ensure brevity in your answer.  0.85. What is the ratio of the Balance of Payment (as % of service exports) in 2006 in Armenia to that in Australia?
Your answer should be very brief. 0.64. What is the ratio of the Balance of Payment (as % of service exports) in 2007 in Armenia to that in Australia?
Offer a terse response. 0.68. What is the ratio of the Balance of Payment (as % of service exports) of 2008 in Armenia to that in Australia?
Your answer should be very brief. 0.78. What is the ratio of the Balance of Payment (as % of service exports) in 2005 in Armenia to that in Austria?
Your answer should be very brief. 0.55. What is the ratio of the Balance of Payment (as % of service exports) of 2006 in Armenia to that in Austria?
Ensure brevity in your answer.  0.45. What is the ratio of the Balance of Payment (as % of service exports) in 2007 in Armenia to that in Austria?
Provide a short and direct response. 0.51. What is the ratio of the Balance of Payment (as % of service exports) of 2008 in Armenia to that in Austria?
Provide a succinct answer. 0.61. What is the ratio of the Balance of Payment (as % of service exports) of 2005 in Armenia to that in Azerbaijan?
Keep it short and to the point. 0.35. What is the ratio of the Balance of Payment (as % of service exports) of 2006 in Armenia to that in Azerbaijan?
Your answer should be very brief. 0.49. What is the ratio of the Balance of Payment (as % of service exports) of 2007 in Armenia to that in Azerbaijan?
Provide a short and direct response. 0.61. What is the ratio of the Balance of Payment (as % of service exports) in 2008 in Armenia to that in Azerbaijan?
Offer a terse response. 0.71. What is the ratio of the Balance of Payment (as % of service exports) in 2005 in Australia to that in Austria?
Provide a succinct answer. 0.65. What is the ratio of the Balance of Payment (as % of service exports) of 2006 in Australia to that in Austria?
Keep it short and to the point. 0.7. What is the ratio of the Balance of Payment (as % of service exports) of 2007 in Australia to that in Austria?
Provide a short and direct response. 0.75. What is the ratio of the Balance of Payment (as % of service exports) of 2008 in Australia to that in Austria?
Give a very brief answer. 0.78. What is the ratio of the Balance of Payment (as % of service exports) of 2005 in Australia to that in Azerbaijan?
Keep it short and to the point. 0.42. What is the ratio of the Balance of Payment (as % of service exports) in 2006 in Australia to that in Azerbaijan?
Your response must be concise. 0.76. What is the ratio of the Balance of Payment (as % of service exports) in 2007 in Australia to that in Azerbaijan?
Give a very brief answer. 0.9. What is the ratio of the Balance of Payment (as % of service exports) of 2008 in Australia to that in Azerbaijan?
Your response must be concise. 0.91. What is the ratio of the Balance of Payment (as % of service exports) in 2005 in Austria to that in Azerbaijan?
Provide a succinct answer. 0.64. What is the ratio of the Balance of Payment (as % of service exports) of 2006 in Austria to that in Azerbaijan?
Your answer should be very brief. 1.09. What is the ratio of the Balance of Payment (as % of service exports) in 2007 in Austria to that in Azerbaijan?
Keep it short and to the point. 1.2. What is the ratio of the Balance of Payment (as % of service exports) of 2008 in Austria to that in Azerbaijan?
Offer a terse response. 1.16. What is the difference between the highest and the second highest Balance of Payment (as % of service exports) in 2005?
Ensure brevity in your answer.  7.7. What is the difference between the highest and the second highest Balance of Payment (as % of service exports) of 2006?
Keep it short and to the point. 7.31. What is the difference between the highest and the second highest Balance of Payment (as % of service exports) in 2007?
Provide a short and direct response. 9.72. What is the difference between the highest and the second highest Balance of Payment (as % of service exports) in 2008?
Your response must be concise. 13.83. What is the difference between the highest and the lowest Balance of Payment (as % of service exports) of 2005?
Your response must be concise. 28.43. What is the difference between the highest and the lowest Balance of Payment (as % of service exports) of 2006?
Provide a short and direct response. 21.18. What is the difference between the highest and the lowest Balance of Payment (as % of service exports) of 2007?
Ensure brevity in your answer.  22.33. What is the difference between the highest and the lowest Balance of Payment (as % of service exports) in 2008?
Your response must be concise. 26.34. 